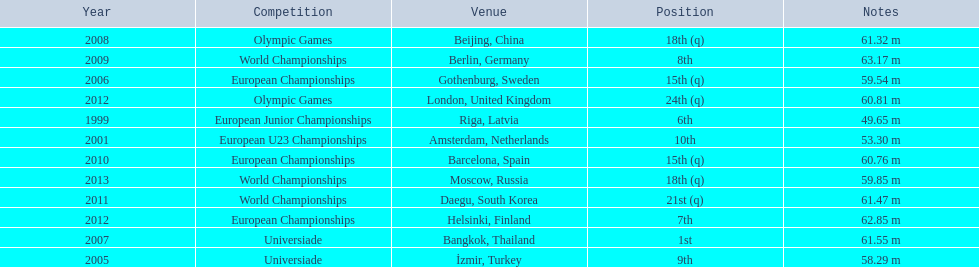What european junior championships? 6th. What waseuropean junior championships best result? 63.17 m. 